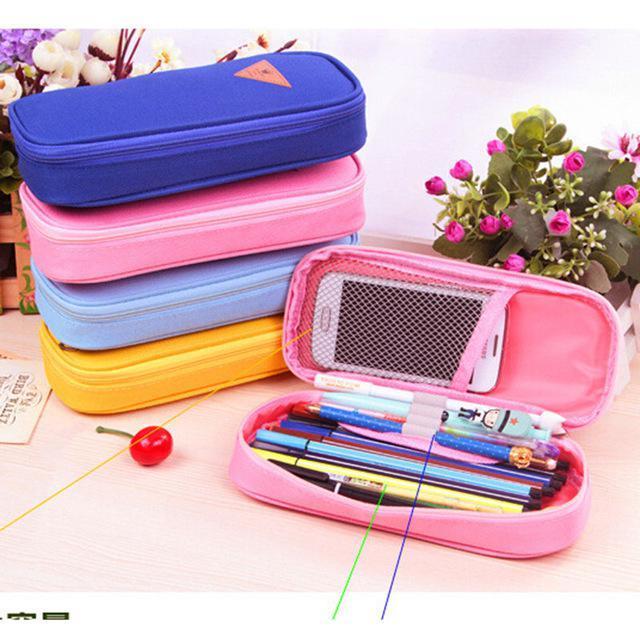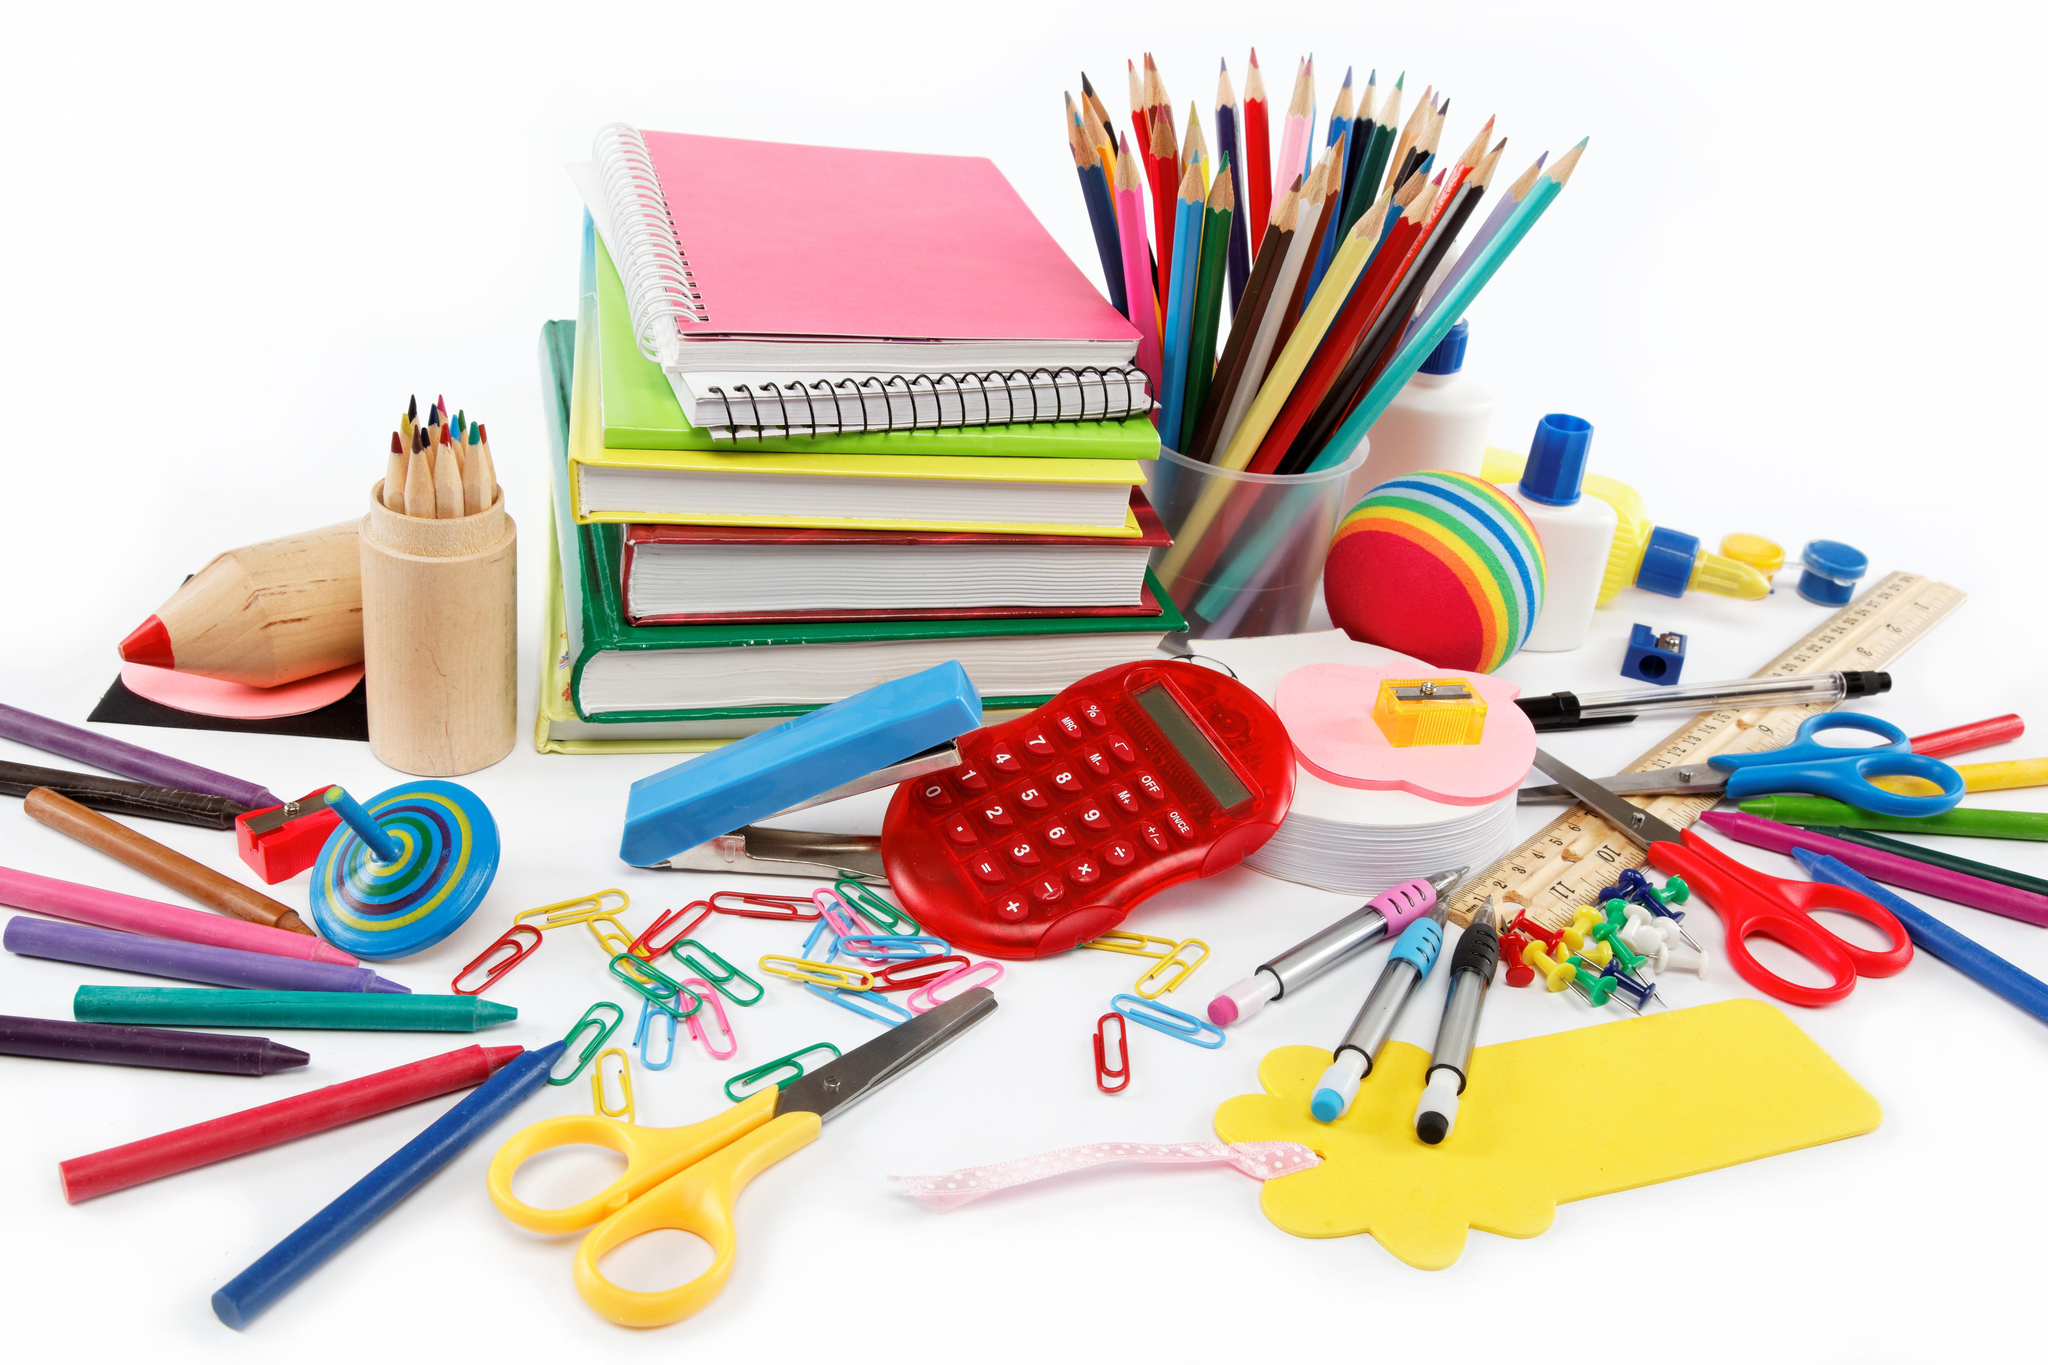The first image is the image on the left, the second image is the image on the right. Analyze the images presented: Is the assertion "There is one image that includes only pencil cases zipped closed, and none are open." valid? Answer yes or no. No. The first image is the image on the left, the second image is the image on the right. Given the left and right images, does the statement "One image shows at least four cases in different solid colors with rounded edges, and only one is open and filled with supplies." hold true? Answer yes or no. Yes. 